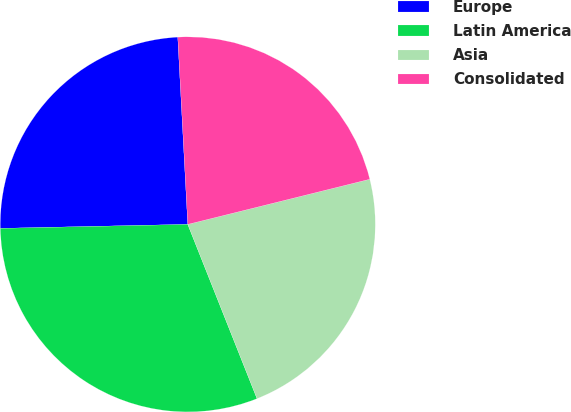<chart> <loc_0><loc_0><loc_500><loc_500><pie_chart><fcel>Europe<fcel>Latin America<fcel>Asia<fcel>Consolidated<nl><fcel>24.49%<fcel>30.68%<fcel>22.85%<fcel>21.98%<nl></chart> 